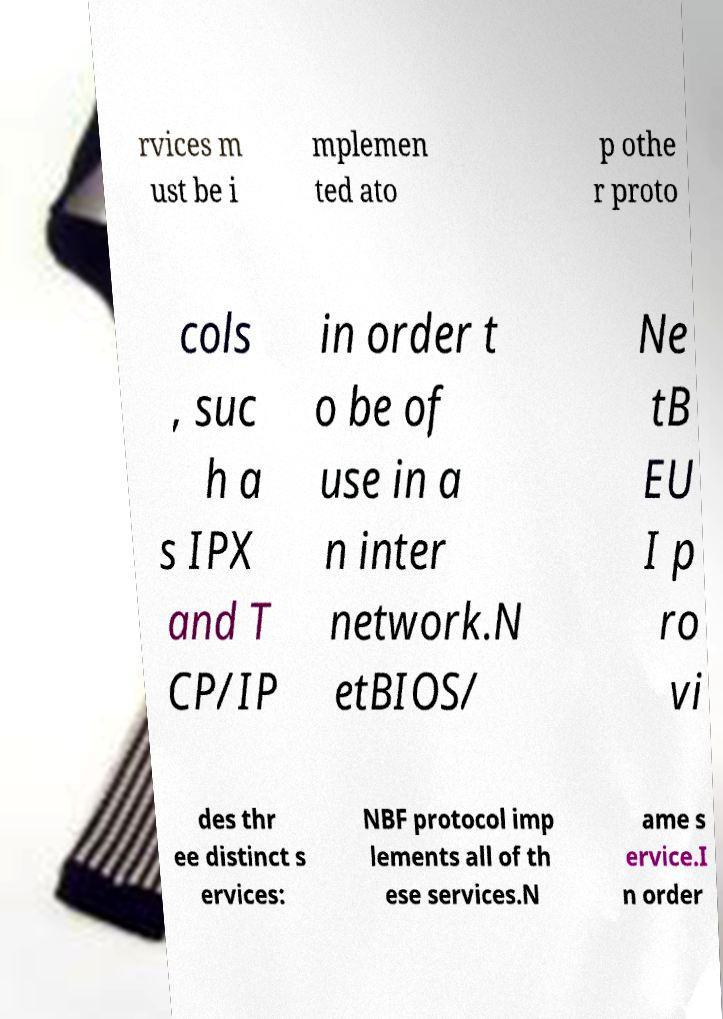There's text embedded in this image that I need extracted. Can you transcribe it verbatim? rvices m ust be i mplemen ted ato p othe r proto cols , suc h a s IPX and T CP/IP in order t o be of use in a n inter network.N etBIOS/ Ne tB EU I p ro vi des thr ee distinct s ervices: NBF protocol imp lements all of th ese services.N ame s ervice.I n order 